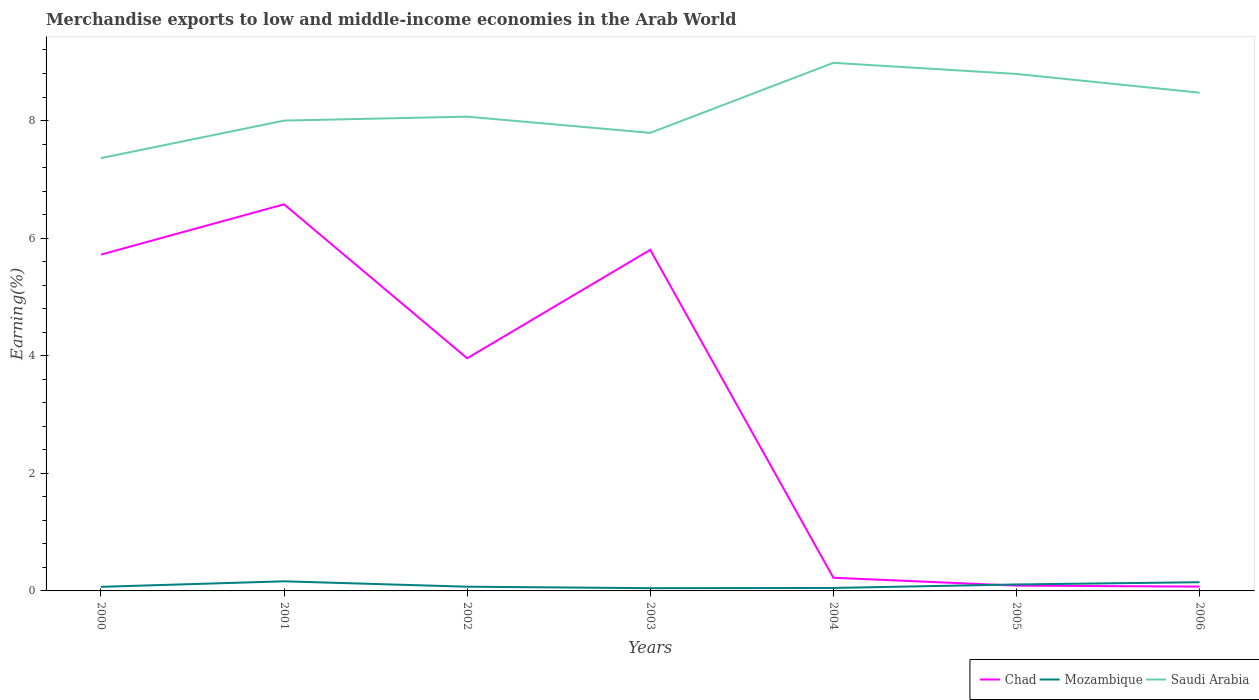How many different coloured lines are there?
Provide a short and direct response. 3. Does the line corresponding to Mozambique intersect with the line corresponding to Chad?
Your answer should be very brief. Yes. Across all years, what is the maximum percentage of amount earned from merchandise exports in Mozambique?
Keep it short and to the point. 0.05. In which year was the percentage of amount earned from merchandise exports in Saudi Arabia maximum?
Make the answer very short. 2000. What is the total percentage of amount earned from merchandise exports in Chad in the graph?
Provide a short and direct response. 5.5. What is the difference between the highest and the second highest percentage of amount earned from merchandise exports in Chad?
Keep it short and to the point. 6.5. Is the percentage of amount earned from merchandise exports in Chad strictly greater than the percentage of amount earned from merchandise exports in Saudi Arabia over the years?
Make the answer very short. Yes. What is the difference between two consecutive major ticks on the Y-axis?
Make the answer very short. 2. Are the values on the major ticks of Y-axis written in scientific E-notation?
Offer a very short reply. No. Does the graph contain any zero values?
Your answer should be very brief. No. Where does the legend appear in the graph?
Provide a succinct answer. Bottom right. How many legend labels are there?
Ensure brevity in your answer.  3. How are the legend labels stacked?
Your response must be concise. Horizontal. What is the title of the graph?
Make the answer very short. Merchandise exports to low and middle-income economies in the Arab World. What is the label or title of the Y-axis?
Keep it short and to the point. Earning(%). What is the Earning(%) of Chad in 2000?
Provide a short and direct response. 5.72. What is the Earning(%) of Mozambique in 2000?
Your answer should be compact. 0.07. What is the Earning(%) of Saudi Arabia in 2000?
Your answer should be very brief. 7.36. What is the Earning(%) of Chad in 2001?
Your response must be concise. 6.57. What is the Earning(%) in Mozambique in 2001?
Keep it short and to the point. 0.16. What is the Earning(%) of Saudi Arabia in 2001?
Keep it short and to the point. 8. What is the Earning(%) in Chad in 2002?
Your answer should be compact. 3.96. What is the Earning(%) in Mozambique in 2002?
Offer a terse response. 0.07. What is the Earning(%) in Saudi Arabia in 2002?
Keep it short and to the point. 8.07. What is the Earning(%) of Chad in 2003?
Give a very brief answer. 5.8. What is the Earning(%) in Mozambique in 2003?
Keep it short and to the point. 0.05. What is the Earning(%) of Saudi Arabia in 2003?
Provide a short and direct response. 7.79. What is the Earning(%) in Chad in 2004?
Ensure brevity in your answer.  0.22. What is the Earning(%) in Mozambique in 2004?
Provide a short and direct response. 0.05. What is the Earning(%) in Saudi Arabia in 2004?
Give a very brief answer. 8.98. What is the Earning(%) of Chad in 2005?
Offer a very short reply. 0.09. What is the Earning(%) of Mozambique in 2005?
Give a very brief answer. 0.11. What is the Earning(%) of Saudi Arabia in 2005?
Offer a terse response. 8.79. What is the Earning(%) of Chad in 2006?
Make the answer very short. 0.07. What is the Earning(%) of Mozambique in 2006?
Offer a very short reply. 0.15. What is the Earning(%) of Saudi Arabia in 2006?
Make the answer very short. 8.47. Across all years, what is the maximum Earning(%) of Chad?
Offer a very short reply. 6.57. Across all years, what is the maximum Earning(%) in Mozambique?
Your answer should be very brief. 0.16. Across all years, what is the maximum Earning(%) in Saudi Arabia?
Give a very brief answer. 8.98. Across all years, what is the minimum Earning(%) of Chad?
Ensure brevity in your answer.  0.07. Across all years, what is the minimum Earning(%) of Mozambique?
Your response must be concise. 0.05. Across all years, what is the minimum Earning(%) of Saudi Arabia?
Offer a very short reply. 7.36. What is the total Earning(%) of Chad in the graph?
Offer a terse response. 22.44. What is the total Earning(%) in Mozambique in the graph?
Ensure brevity in your answer.  0.66. What is the total Earning(%) in Saudi Arabia in the graph?
Your response must be concise. 57.46. What is the difference between the Earning(%) of Chad in 2000 and that in 2001?
Give a very brief answer. -0.86. What is the difference between the Earning(%) of Mozambique in 2000 and that in 2001?
Provide a succinct answer. -0.09. What is the difference between the Earning(%) of Saudi Arabia in 2000 and that in 2001?
Provide a short and direct response. -0.64. What is the difference between the Earning(%) of Chad in 2000 and that in 2002?
Keep it short and to the point. 1.76. What is the difference between the Earning(%) of Mozambique in 2000 and that in 2002?
Offer a very short reply. -0. What is the difference between the Earning(%) of Saudi Arabia in 2000 and that in 2002?
Provide a succinct answer. -0.71. What is the difference between the Earning(%) in Chad in 2000 and that in 2003?
Keep it short and to the point. -0.08. What is the difference between the Earning(%) of Mozambique in 2000 and that in 2003?
Offer a terse response. 0.02. What is the difference between the Earning(%) of Saudi Arabia in 2000 and that in 2003?
Your answer should be very brief. -0.43. What is the difference between the Earning(%) of Chad in 2000 and that in 2004?
Keep it short and to the point. 5.5. What is the difference between the Earning(%) of Mozambique in 2000 and that in 2004?
Give a very brief answer. 0.02. What is the difference between the Earning(%) in Saudi Arabia in 2000 and that in 2004?
Your answer should be very brief. -1.62. What is the difference between the Earning(%) of Chad in 2000 and that in 2005?
Your answer should be compact. 5.63. What is the difference between the Earning(%) of Mozambique in 2000 and that in 2005?
Ensure brevity in your answer.  -0.04. What is the difference between the Earning(%) in Saudi Arabia in 2000 and that in 2005?
Offer a very short reply. -1.43. What is the difference between the Earning(%) of Chad in 2000 and that in 2006?
Offer a terse response. 5.65. What is the difference between the Earning(%) of Mozambique in 2000 and that in 2006?
Provide a succinct answer. -0.08. What is the difference between the Earning(%) of Saudi Arabia in 2000 and that in 2006?
Your response must be concise. -1.11. What is the difference between the Earning(%) in Chad in 2001 and that in 2002?
Offer a very short reply. 2.62. What is the difference between the Earning(%) in Mozambique in 2001 and that in 2002?
Give a very brief answer. 0.09. What is the difference between the Earning(%) of Saudi Arabia in 2001 and that in 2002?
Provide a succinct answer. -0.07. What is the difference between the Earning(%) in Chad in 2001 and that in 2003?
Your answer should be very brief. 0.77. What is the difference between the Earning(%) in Mozambique in 2001 and that in 2003?
Keep it short and to the point. 0.12. What is the difference between the Earning(%) of Saudi Arabia in 2001 and that in 2003?
Ensure brevity in your answer.  0.21. What is the difference between the Earning(%) of Chad in 2001 and that in 2004?
Ensure brevity in your answer.  6.35. What is the difference between the Earning(%) of Mozambique in 2001 and that in 2004?
Make the answer very short. 0.11. What is the difference between the Earning(%) of Saudi Arabia in 2001 and that in 2004?
Offer a very short reply. -0.98. What is the difference between the Earning(%) in Chad in 2001 and that in 2005?
Ensure brevity in your answer.  6.49. What is the difference between the Earning(%) in Mozambique in 2001 and that in 2005?
Your answer should be very brief. 0.05. What is the difference between the Earning(%) in Saudi Arabia in 2001 and that in 2005?
Offer a very short reply. -0.79. What is the difference between the Earning(%) of Chad in 2001 and that in 2006?
Your response must be concise. 6.5. What is the difference between the Earning(%) of Mozambique in 2001 and that in 2006?
Make the answer very short. 0.02. What is the difference between the Earning(%) of Saudi Arabia in 2001 and that in 2006?
Your answer should be very brief. -0.47. What is the difference between the Earning(%) in Chad in 2002 and that in 2003?
Your response must be concise. -1.84. What is the difference between the Earning(%) of Mozambique in 2002 and that in 2003?
Your response must be concise. 0.02. What is the difference between the Earning(%) of Saudi Arabia in 2002 and that in 2003?
Your response must be concise. 0.28. What is the difference between the Earning(%) of Chad in 2002 and that in 2004?
Offer a very short reply. 3.73. What is the difference between the Earning(%) of Mozambique in 2002 and that in 2004?
Ensure brevity in your answer.  0.02. What is the difference between the Earning(%) of Saudi Arabia in 2002 and that in 2004?
Your response must be concise. -0.92. What is the difference between the Earning(%) in Chad in 2002 and that in 2005?
Your answer should be compact. 3.87. What is the difference between the Earning(%) of Mozambique in 2002 and that in 2005?
Make the answer very short. -0.04. What is the difference between the Earning(%) of Saudi Arabia in 2002 and that in 2005?
Your response must be concise. -0.73. What is the difference between the Earning(%) of Chad in 2002 and that in 2006?
Give a very brief answer. 3.88. What is the difference between the Earning(%) in Mozambique in 2002 and that in 2006?
Ensure brevity in your answer.  -0.08. What is the difference between the Earning(%) of Saudi Arabia in 2002 and that in 2006?
Offer a terse response. -0.41. What is the difference between the Earning(%) of Chad in 2003 and that in 2004?
Ensure brevity in your answer.  5.58. What is the difference between the Earning(%) in Mozambique in 2003 and that in 2004?
Give a very brief answer. -0. What is the difference between the Earning(%) in Saudi Arabia in 2003 and that in 2004?
Ensure brevity in your answer.  -1.19. What is the difference between the Earning(%) of Chad in 2003 and that in 2005?
Your answer should be compact. 5.71. What is the difference between the Earning(%) of Mozambique in 2003 and that in 2005?
Your answer should be very brief. -0.06. What is the difference between the Earning(%) in Saudi Arabia in 2003 and that in 2005?
Provide a short and direct response. -1. What is the difference between the Earning(%) of Chad in 2003 and that in 2006?
Make the answer very short. 5.73. What is the difference between the Earning(%) in Mozambique in 2003 and that in 2006?
Offer a terse response. -0.1. What is the difference between the Earning(%) in Saudi Arabia in 2003 and that in 2006?
Your answer should be compact. -0.68. What is the difference between the Earning(%) in Chad in 2004 and that in 2005?
Your answer should be very brief. 0.13. What is the difference between the Earning(%) of Mozambique in 2004 and that in 2005?
Your response must be concise. -0.06. What is the difference between the Earning(%) in Saudi Arabia in 2004 and that in 2005?
Your response must be concise. 0.19. What is the difference between the Earning(%) in Chad in 2004 and that in 2006?
Provide a short and direct response. 0.15. What is the difference between the Earning(%) of Mozambique in 2004 and that in 2006?
Your answer should be very brief. -0.1. What is the difference between the Earning(%) in Saudi Arabia in 2004 and that in 2006?
Ensure brevity in your answer.  0.51. What is the difference between the Earning(%) in Chad in 2005 and that in 2006?
Offer a terse response. 0.02. What is the difference between the Earning(%) in Mozambique in 2005 and that in 2006?
Your response must be concise. -0.04. What is the difference between the Earning(%) of Saudi Arabia in 2005 and that in 2006?
Offer a very short reply. 0.32. What is the difference between the Earning(%) in Chad in 2000 and the Earning(%) in Mozambique in 2001?
Offer a terse response. 5.56. What is the difference between the Earning(%) in Chad in 2000 and the Earning(%) in Saudi Arabia in 2001?
Offer a very short reply. -2.28. What is the difference between the Earning(%) of Mozambique in 2000 and the Earning(%) of Saudi Arabia in 2001?
Give a very brief answer. -7.93. What is the difference between the Earning(%) in Chad in 2000 and the Earning(%) in Mozambique in 2002?
Offer a very short reply. 5.65. What is the difference between the Earning(%) of Chad in 2000 and the Earning(%) of Saudi Arabia in 2002?
Offer a very short reply. -2.35. What is the difference between the Earning(%) in Mozambique in 2000 and the Earning(%) in Saudi Arabia in 2002?
Ensure brevity in your answer.  -8. What is the difference between the Earning(%) of Chad in 2000 and the Earning(%) of Mozambique in 2003?
Provide a succinct answer. 5.67. What is the difference between the Earning(%) of Chad in 2000 and the Earning(%) of Saudi Arabia in 2003?
Provide a short and direct response. -2.07. What is the difference between the Earning(%) of Mozambique in 2000 and the Earning(%) of Saudi Arabia in 2003?
Your answer should be very brief. -7.72. What is the difference between the Earning(%) in Chad in 2000 and the Earning(%) in Mozambique in 2004?
Make the answer very short. 5.67. What is the difference between the Earning(%) in Chad in 2000 and the Earning(%) in Saudi Arabia in 2004?
Keep it short and to the point. -3.26. What is the difference between the Earning(%) in Mozambique in 2000 and the Earning(%) in Saudi Arabia in 2004?
Give a very brief answer. -8.91. What is the difference between the Earning(%) of Chad in 2000 and the Earning(%) of Mozambique in 2005?
Offer a terse response. 5.61. What is the difference between the Earning(%) in Chad in 2000 and the Earning(%) in Saudi Arabia in 2005?
Offer a very short reply. -3.07. What is the difference between the Earning(%) of Mozambique in 2000 and the Earning(%) of Saudi Arabia in 2005?
Give a very brief answer. -8.72. What is the difference between the Earning(%) in Chad in 2000 and the Earning(%) in Mozambique in 2006?
Provide a short and direct response. 5.57. What is the difference between the Earning(%) in Chad in 2000 and the Earning(%) in Saudi Arabia in 2006?
Provide a short and direct response. -2.75. What is the difference between the Earning(%) of Mozambique in 2000 and the Earning(%) of Saudi Arabia in 2006?
Ensure brevity in your answer.  -8.4. What is the difference between the Earning(%) in Chad in 2001 and the Earning(%) in Mozambique in 2002?
Your answer should be very brief. 6.5. What is the difference between the Earning(%) in Chad in 2001 and the Earning(%) in Saudi Arabia in 2002?
Your answer should be compact. -1.49. What is the difference between the Earning(%) in Mozambique in 2001 and the Earning(%) in Saudi Arabia in 2002?
Offer a terse response. -7.9. What is the difference between the Earning(%) in Chad in 2001 and the Earning(%) in Mozambique in 2003?
Offer a very short reply. 6.53. What is the difference between the Earning(%) in Chad in 2001 and the Earning(%) in Saudi Arabia in 2003?
Your answer should be compact. -1.22. What is the difference between the Earning(%) of Mozambique in 2001 and the Earning(%) of Saudi Arabia in 2003?
Give a very brief answer. -7.63. What is the difference between the Earning(%) of Chad in 2001 and the Earning(%) of Mozambique in 2004?
Offer a terse response. 6.52. What is the difference between the Earning(%) of Chad in 2001 and the Earning(%) of Saudi Arabia in 2004?
Ensure brevity in your answer.  -2.41. What is the difference between the Earning(%) in Mozambique in 2001 and the Earning(%) in Saudi Arabia in 2004?
Your answer should be compact. -8.82. What is the difference between the Earning(%) in Chad in 2001 and the Earning(%) in Mozambique in 2005?
Your response must be concise. 6.46. What is the difference between the Earning(%) in Chad in 2001 and the Earning(%) in Saudi Arabia in 2005?
Your response must be concise. -2.22. What is the difference between the Earning(%) of Mozambique in 2001 and the Earning(%) of Saudi Arabia in 2005?
Keep it short and to the point. -8.63. What is the difference between the Earning(%) of Chad in 2001 and the Earning(%) of Mozambique in 2006?
Ensure brevity in your answer.  6.43. What is the difference between the Earning(%) of Chad in 2001 and the Earning(%) of Saudi Arabia in 2006?
Keep it short and to the point. -1.9. What is the difference between the Earning(%) in Mozambique in 2001 and the Earning(%) in Saudi Arabia in 2006?
Provide a succinct answer. -8.31. What is the difference between the Earning(%) of Chad in 2002 and the Earning(%) of Mozambique in 2003?
Give a very brief answer. 3.91. What is the difference between the Earning(%) of Chad in 2002 and the Earning(%) of Saudi Arabia in 2003?
Your answer should be very brief. -3.83. What is the difference between the Earning(%) in Mozambique in 2002 and the Earning(%) in Saudi Arabia in 2003?
Offer a very short reply. -7.72. What is the difference between the Earning(%) in Chad in 2002 and the Earning(%) in Mozambique in 2004?
Keep it short and to the point. 3.91. What is the difference between the Earning(%) in Chad in 2002 and the Earning(%) in Saudi Arabia in 2004?
Give a very brief answer. -5.02. What is the difference between the Earning(%) of Mozambique in 2002 and the Earning(%) of Saudi Arabia in 2004?
Provide a short and direct response. -8.91. What is the difference between the Earning(%) of Chad in 2002 and the Earning(%) of Mozambique in 2005?
Offer a very short reply. 3.85. What is the difference between the Earning(%) in Chad in 2002 and the Earning(%) in Saudi Arabia in 2005?
Make the answer very short. -4.84. What is the difference between the Earning(%) of Mozambique in 2002 and the Earning(%) of Saudi Arabia in 2005?
Your response must be concise. -8.72. What is the difference between the Earning(%) of Chad in 2002 and the Earning(%) of Mozambique in 2006?
Your answer should be compact. 3.81. What is the difference between the Earning(%) of Chad in 2002 and the Earning(%) of Saudi Arabia in 2006?
Your answer should be compact. -4.52. What is the difference between the Earning(%) of Mozambique in 2002 and the Earning(%) of Saudi Arabia in 2006?
Your answer should be compact. -8.4. What is the difference between the Earning(%) in Chad in 2003 and the Earning(%) in Mozambique in 2004?
Provide a short and direct response. 5.75. What is the difference between the Earning(%) of Chad in 2003 and the Earning(%) of Saudi Arabia in 2004?
Your answer should be compact. -3.18. What is the difference between the Earning(%) in Mozambique in 2003 and the Earning(%) in Saudi Arabia in 2004?
Make the answer very short. -8.93. What is the difference between the Earning(%) in Chad in 2003 and the Earning(%) in Mozambique in 2005?
Offer a very short reply. 5.69. What is the difference between the Earning(%) of Chad in 2003 and the Earning(%) of Saudi Arabia in 2005?
Ensure brevity in your answer.  -2.99. What is the difference between the Earning(%) in Mozambique in 2003 and the Earning(%) in Saudi Arabia in 2005?
Keep it short and to the point. -8.75. What is the difference between the Earning(%) of Chad in 2003 and the Earning(%) of Mozambique in 2006?
Keep it short and to the point. 5.65. What is the difference between the Earning(%) in Chad in 2003 and the Earning(%) in Saudi Arabia in 2006?
Make the answer very short. -2.67. What is the difference between the Earning(%) of Mozambique in 2003 and the Earning(%) of Saudi Arabia in 2006?
Give a very brief answer. -8.43. What is the difference between the Earning(%) of Chad in 2004 and the Earning(%) of Mozambique in 2005?
Provide a short and direct response. 0.11. What is the difference between the Earning(%) of Chad in 2004 and the Earning(%) of Saudi Arabia in 2005?
Offer a very short reply. -8.57. What is the difference between the Earning(%) in Mozambique in 2004 and the Earning(%) in Saudi Arabia in 2005?
Ensure brevity in your answer.  -8.74. What is the difference between the Earning(%) in Chad in 2004 and the Earning(%) in Mozambique in 2006?
Make the answer very short. 0.08. What is the difference between the Earning(%) in Chad in 2004 and the Earning(%) in Saudi Arabia in 2006?
Provide a succinct answer. -8.25. What is the difference between the Earning(%) of Mozambique in 2004 and the Earning(%) of Saudi Arabia in 2006?
Make the answer very short. -8.42. What is the difference between the Earning(%) of Chad in 2005 and the Earning(%) of Mozambique in 2006?
Your answer should be compact. -0.06. What is the difference between the Earning(%) in Chad in 2005 and the Earning(%) in Saudi Arabia in 2006?
Your response must be concise. -8.38. What is the difference between the Earning(%) of Mozambique in 2005 and the Earning(%) of Saudi Arabia in 2006?
Provide a short and direct response. -8.36. What is the average Earning(%) of Chad per year?
Your answer should be very brief. 3.21. What is the average Earning(%) of Mozambique per year?
Offer a terse response. 0.09. What is the average Earning(%) in Saudi Arabia per year?
Offer a terse response. 8.21. In the year 2000, what is the difference between the Earning(%) in Chad and Earning(%) in Mozambique?
Provide a succinct answer. 5.65. In the year 2000, what is the difference between the Earning(%) of Chad and Earning(%) of Saudi Arabia?
Offer a terse response. -1.64. In the year 2000, what is the difference between the Earning(%) of Mozambique and Earning(%) of Saudi Arabia?
Offer a terse response. -7.29. In the year 2001, what is the difference between the Earning(%) of Chad and Earning(%) of Mozambique?
Offer a very short reply. 6.41. In the year 2001, what is the difference between the Earning(%) of Chad and Earning(%) of Saudi Arabia?
Offer a very short reply. -1.42. In the year 2001, what is the difference between the Earning(%) in Mozambique and Earning(%) in Saudi Arabia?
Offer a terse response. -7.84. In the year 2002, what is the difference between the Earning(%) in Chad and Earning(%) in Mozambique?
Offer a very short reply. 3.88. In the year 2002, what is the difference between the Earning(%) of Chad and Earning(%) of Saudi Arabia?
Provide a succinct answer. -4.11. In the year 2002, what is the difference between the Earning(%) of Mozambique and Earning(%) of Saudi Arabia?
Keep it short and to the point. -7.99. In the year 2003, what is the difference between the Earning(%) in Chad and Earning(%) in Mozambique?
Offer a very short reply. 5.75. In the year 2003, what is the difference between the Earning(%) of Chad and Earning(%) of Saudi Arabia?
Provide a succinct answer. -1.99. In the year 2003, what is the difference between the Earning(%) of Mozambique and Earning(%) of Saudi Arabia?
Provide a short and direct response. -7.74. In the year 2004, what is the difference between the Earning(%) of Chad and Earning(%) of Mozambique?
Give a very brief answer. 0.17. In the year 2004, what is the difference between the Earning(%) in Chad and Earning(%) in Saudi Arabia?
Make the answer very short. -8.76. In the year 2004, what is the difference between the Earning(%) in Mozambique and Earning(%) in Saudi Arabia?
Your answer should be compact. -8.93. In the year 2005, what is the difference between the Earning(%) in Chad and Earning(%) in Mozambique?
Your answer should be compact. -0.02. In the year 2005, what is the difference between the Earning(%) in Chad and Earning(%) in Saudi Arabia?
Keep it short and to the point. -8.7. In the year 2005, what is the difference between the Earning(%) in Mozambique and Earning(%) in Saudi Arabia?
Your response must be concise. -8.68. In the year 2006, what is the difference between the Earning(%) in Chad and Earning(%) in Mozambique?
Provide a succinct answer. -0.07. In the year 2006, what is the difference between the Earning(%) of Chad and Earning(%) of Saudi Arabia?
Your answer should be very brief. -8.4. In the year 2006, what is the difference between the Earning(%) in Mozambique and Earning(%) in Saudi Arabia?
Offer a very short reply. -8.33. What is the ratio of the Earning(%) in Chad in 2000 to that in 2001?
Give a very brief answer. 0.87. What is the ratio of the Earning(%) of Mozambique in 2000 to that in 2001?
Your answer should be compact. 0.43. What is the ratio of the Earning(%) in Saudi Arabia in 2000 to that in 2001?
Offer a very short reply. 0.92. What is the ratio of the Earning(%) of Chad in 2000 to that in 2002?
Ensure brevity in your answer.  1.45. What is the ratio of the Earning(%) of Mozambique in 2000 to that in 2002?
Your answer should be very brief. 0.97. What is the ratio of the Earning(%) in Saudi Arabia in 2000 to that in 2002?
Ensure brevity in your answer.  0.91. What is the ratio of the Earning(%) in Mozambique in 2000 to that in 2003?
Give a very brief answer. 1.49. What is the ratio of the Earning(%) of Saudi Arabia in 2000 to that in 2003?
Provide a short and direct response. 0.94. What is the ratio of the Earning(%) in Chad in 2000 to that in 2004?
Ensure brevity in your answer.  25.53. What is the ratio of the Earning(%) in Mozambique in 2000 to that in 2004?
Offer a terse response. 1.38. What is the ratio of the Earning(%) of Saudi Arabia in 2000 to that in 2004?
Make the answer very short. 0.82. What is the ratio of the Earning(%) of Chad in 2000 to that in 2005?
Your response must be concise. 63.54. What is the ratio of the Earning(%) of Mozambique in 2000 to that in 2005?
Provide a succinct answer. 0.63. What is the ratio of the Earning(%) in Saudi Arabia in 2000 to that in 2005?
Your answer should be compact. 0.84. What is the ratio of the Earning(%) of Chad in 2000 to that in 2006?
Offer a very short reply. 78.26. What is the ratio of the Earning(%) in Mozambique in 2000 to that in 2006?
Ensure brevity in your answer.  0.47. What is the ratio of the Earning(%) of Saudi Arabia in 2000 to that in 2006?
Keep it short and to the point. 0.87. What is the ratio of the Earning(%) in Chad in 2001 to that in 2002?
Provide a succinct answer. 1.66. What is the ratio of the Earning(%) of Mozambique in 2001 to that in 2002?
Your answer should be compact. 2.28. What is the ratio of the Earning(%) of Saudi Arabia in 2001 to that in 2002?
Keep it short and to the point. 0.99. What is the ratio of the Earning(%) in Chad in 2001 to that in 2003?
Keep it short and to the point. 1.13. What is the ratio of the Earning(%) in Mozambique in 2001 to that in 2003?
Make the answer very short. 3.49. What is the ratio of the Earning(%) of Saudi Arabia in 2001 to that in 2003?
Keep it short and to the point. 1.03. What is the ratio of the Earning(%) in Chad in 2001 to that in 2004?
Ensure brevity in your answer.  29.34. What is the ratio of the Earning(%) in Mozambique in 2001 to that in 2004?
Your answer should be compact. 3.24. What is the ratio of the Earning(%) of Saudi Arabia in 2001 to that in 2004?
Provide a short and direct response. 0.89. What is the ratio of the Earning(%) in Chad in 2001 to that in 2005?
Provide a short and direct response. 73.04. What is the ratio of the Earning(%) in Mozambique in 2001 to that in 2005?
Provide a succinct answer. 1.49. What is the ratio of the Earning(%) of Saudi Arabia in 2001 to that in 2005?
Provide a succinct answer. 0.91. What is the ratio of the Earning(%) of Chad in 2001 to that in 2006?
Keep it short and to the point. 89.97. What is the ratio of the Earning(%) in Mozambique in 2001 to that in 2006?
Ensure brevity in your answer.  1.1. What is the ratio of the Earning(%) in Saudi Arabia in 2001 to that in 2006?
Provide a short and direct response. 0.94. What is the ratio of the Earning(%) of Chad in 2002 to that in 2003?
Provide a succinct answer. 0.68. What is the ratio of the Earning(%) of Mozambique in 2002 to that in 2003?
Keep it short and to the point. 1.53. What is the ratio of the Earning(%) of Saudi Arabia in 2002 to that in 2003?
Give a very brief answer. 1.04. What is the ratio of the Earning(%) in Chad in 2002 to that in 2004?
Make the answer very short. 17.66. What is the ratio of the Earning(%) in Mozambique in 2002 to that in 2004?
Keep it short and to the point. 1.42. What is the ratio of the Earning(%) in Saudi Arabia in 2002 to that in 2004?
Give a very brief answer. 0.9. What is the ratio of the Earning(%) of Chad in 2002 to that in 2005?
Ensure brevity in your answer.  43.95. What is the ratio of the Earning(%) of Mozambique in 2002 to that in 2005?
Offer a terse response. 0.65. What is the ratio of the Earning(%) of Saudi Arabia in 2002 to that in 2005?
Keep it short and to the point. 0.92. What is the ratio of the Earning(%) of Chad in 2002 to that in 2006?
Make the answer very short. 54.14. What is the ratio of the Earning(%) of Mozambique in 2002 to that in 2006?
Keep it short and to the point. 0.48. What is the ratio of the Earning(%) of Saudi Arabia in 2002 to that in 2006?
Give a very brief answer. 0.95. What is the ratio of the Earning(%) in Chad in 2003 to that in 2004?
Provide a succinct answer. 25.89. What is the ratio of the Earning(%) in Mozambique in 2003 to that in 2004?
Your response must be concise. 0.93. What is the ratio of the Earning(%) of Saudi Arabia in 2003 to that in 2004?
Your answer should be very brief. 0.87. What is the ratio of the Earning(%) of Chad in 2003 to that in 2005?
Your answer should be very brief. 64.44. What is the ratio of the Earning(%) in Mozambique in 2003 to that in 2005?
Make the answer very short. 0.43. What is the ratio of the Earning(%) of Saudi Arabia in 2003 to that in 2005?
Offer a very short reply. 0.89. What is the ratio of the Earning(%) in Chad in 2003 to that in 2006?
Offer a very short reply. 79.38. What is the ratio of the Earning(%) of Mozambique in 2003 to that in 2006?
Offer a terse response. 0.32. What is the ratio of the Earning(%) of Saudi Arabia in 2003 to that in 2006?
Your answer should be compact. 0.92. What is the ratio of the Earning(%) in Chad in 2004 to that in 2005?
Offer a terse response. 2.49. What is the ratio of the Earning(%) of Mozambique in 2004 to that in 2005?
Your answer should be very brief. 0.46. What is the ratio of the Earning(%) of Saudi Arabia in 2004 to that in 2005?
Your answer should be compact. 1.02. What is the ratio of the Earning(%) of Chad in 2004 to that in 2006?
Give a very brief answer. 3.07. What is the ratio of the Earning(%) of Mozambique in 2004 to that in 2006?
Make the answer very short. 0.34. What is the ratio of the Earning(%) of Saudi Arabia in 2004 to that in 2006?
Make the answer very short. 1.06. What is the ratio of the Earning(%) of Chad in 2005 to that in 2006?
Give a very brief answer. 1.23. What is the ratio of the Earning(%) of Mozambique in 2005 to that in 2006?
Provide a succinct answer. 0.74. What is the ratio of the Earning(%) in Saudi Arabia in 2005 to that in 2006?
Offer a very short reply. 1.04. What is the difference between the highest and the second highest Earning(%) of Chad?
Provide a short and direct response. 0.77. What is the difference between the highest and the second highest Earning(%) in Mozambique?
Your answer should be very brief. 0.02. What is the difference between the highest and the second highest Earning(%) of Saudi Arabia?
Offer a terse response. 0.19. What is the difference between the highest and the lowest Earning(%) of Chad?
Provide a short and direct response. 6.5. What is the difference between the highest and the lowest Earning(%) of Mozambique?
Offer a very short reply. 0.12. What is the difference between the highest and the lowest Earning(%) in Saudi Arabia?
Give a very brief answer. 1.62. 